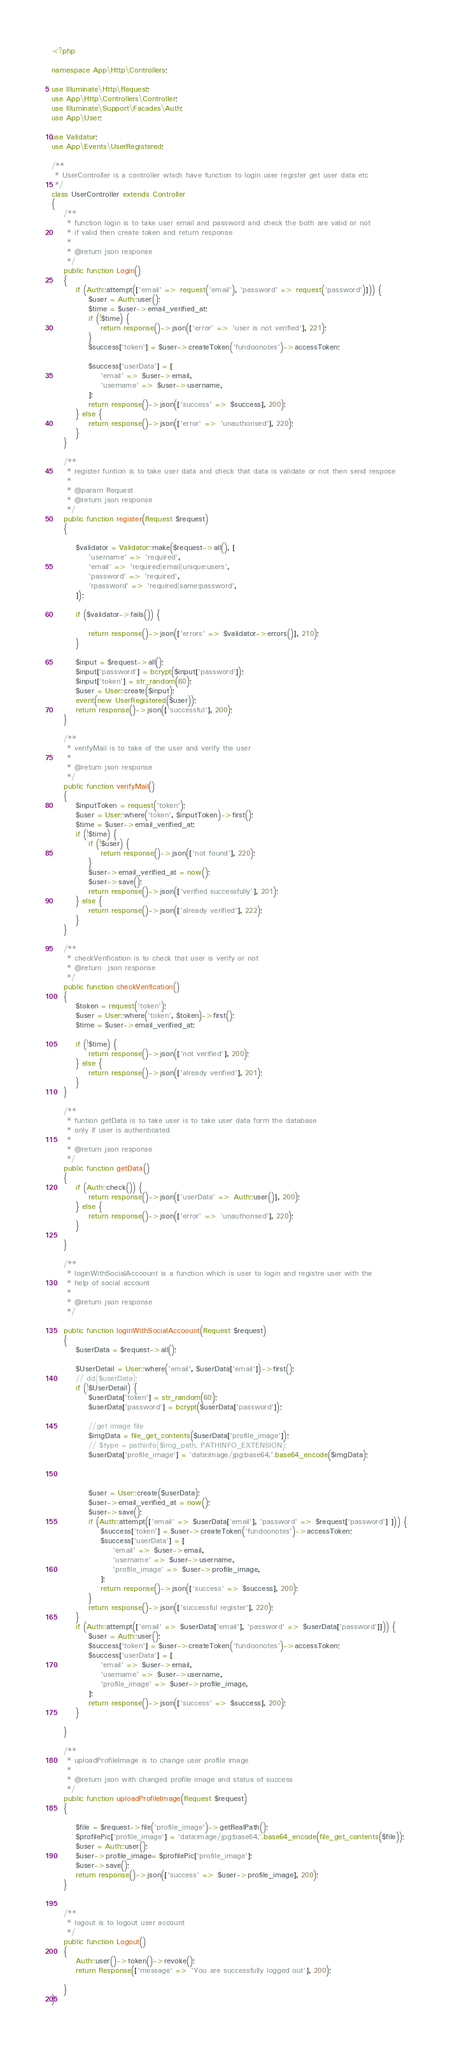Convert code to text. <code><loc_0><loc_0><loc_500><loc_500><_PHP_><?php

namespace App\Http\Controllers;

use Illuminate\Http\Request;
use App\Http\Controllers\Controller;
use Illuminate\Support\Facades\Auth;
use App\User;

use Validator;
use App\Events\UserRegistered;

/**
 * UserController is a controller which have function to login user register get user data etc 
 */
class UserController extends Controller
{
    /**
     * function login is to take user email and password and check the both are valid or not 
     * if valid then create token and return response
     * 
     * @return json response
     */
    public function Login()
    {
        if (Auth::attempt(['email' => request('email'), 'password' => request('password')])) {
            $user = Auth::user();
            $time = $user->email_verified_at;
            if (!$time) {
                return response()->json(['error' => 'user is not verified'], 221);
            }
            $success['token'] = $user->createToken('fundoonotes')->accessToken;

            $success['userData'] = [
                'email' => $user->email,
                'username' => $user->username,
            ];
            return response()->json(['success' => $success], 200);
        } else {
            return response()->json(['error' => 'unauthorised'], 220);
        }
    }

    /**
     * register funtion is to take user data and check that data is validate or not then send respose
     * 
     * @param Request 
     * @return json response
     */
    public function register(Request $request)
    {

        $validator = Validator::make($request->all(), [
            'username' => 'required',
            'email' => 'required|email|unique:users',
            'password' => 'required',
            'rpassword' => 'required|same:password',
        ]);

        if ($validator->fails()) {

            return response()->json(['errors' => $validator->errors()], 210);
        }

        $input = $request->all();
        $input['password'] = bcrypt($input['password']);
        $input['token'] = str_random(60);
        $user = User::create($input);
        event(new UserRegistered($user));
        return response()->json(['successful'], 200);
    }

    /**
     * verifyMail is to take of the user and verify the user 
     * 
     * @return json response
     */
    public function verifyMail()
    {
        $inputToken = request('token');
        $user = User::where('token', $inputToken)->first();
        $time = $user->email_verified_at;
        if (!$time) {
            if (!$user) {
                return response()->json(['not found'], 220);
            }
            $user->email_verified_at = now();
            $user->save();
            return response()->json(['verified successfully'], 201);
        } else {
            return response()->json(['already verified'], 222);
        }
    }

    /**
     * checkVerification is to check that user is verify or not 
     * @return  json response 
     */
    public function checkVerification()
    {
        $token = request('token');
        $user = User::where('token', $token)->first();
        $time = $user->email_verified_at;

        if (!$time) {
            return response()->json(['not verified'], 200);
        } else {
            return response()->json(['already verified'], 201);
        }
    }

    /**
     * funtion getData is to take user is to take user data form the database
     * only if user is authenticated 
     * 
     * @return json response
     */
    public function getData()
    {
        if (Auth::check()) {
            return response()->json(['userData' => Auth::user()], 200);
        } else {
            return response()->json(['error' => 'unauthorised'], 220);
        }

    }

    /**
     * loginWithSocialAccoount is a function which is user to login and registre user with the 
     * help of social account 
     * 
     * @return json response
     */

    public function loginWithSocialAccoount(Request $request)
    {
        $userData = $request->all();
      
        $UserDetail = User::where('email', $userData['email'])->first();
        // dd($userData);
        if (!$UserDetail) {
            $userData['token'] = str_random(60);
            $userData['password'] = bcrypt($userData['password']);

            //get image file 
            $imgData = file_get_contents($userData['profile_image']);
            // $type = pathinfo($img_path, PATHINFO_EXTENSION);
            $userData['profile_image'] = 'data:image/jpg;base64,'.base64_encode($imgData);



            $user = User::create($userData);
            $user->email_verified_at = now();
            $user->save();
            if (Auth::attempt(['email' => $userData['email'], 'password' => $request['password'] ])) {
                $success['token'] = $user->createToken('fundoonotes')->accessToken;
                $success['userData'] = [
                    'email' => $user->email,
                    'username' => $user->username,
                    'profile_image' => $user->profile_image,
                ];
                return response()->json(['success' => $success], 200);
            }
            return response()->json(['successful register'], 220);
        }
        if (Auth::attempt(['email' => $userData['email'], 'password' => $userData['password']])) {
            $user = Auth::user();
            $success['token'] = $user->createToken('fundoonotes')->accessToken;
            $success['userData'] = [
                'email' => $user->email,
                'username' => $user->username,
                'profile_image' => $user->profile_image,
            ];
            return response()->json(['success' => $success], 200);
        }

    }

    /**
     * uploadProfileImage is to change user profile image
     * 
     * @return json with changed profile image and status of success 
     */
    public function uploadProfileImage(Request $request)
    {   
        
        $file = $request->file('profile_image')->getRealPath();
        $profilePic['profile_image'] = 'data:image/jpg;base64,'.base64_encode(file_get_contents($file));
        $user = Auth::user();
        $user->profile_image= $profilePic['profile_image'];
        $user->save();
        return response()->json(['success' => $user->profile_image], 200);
    }


    /**
     * logout is to logout user account
     */
    public function Logout()
    {
        Auth::user()->token()->revoke();
        return Response(['message' => 'You are successfully logged out'], 200);

    }
}
</code> 